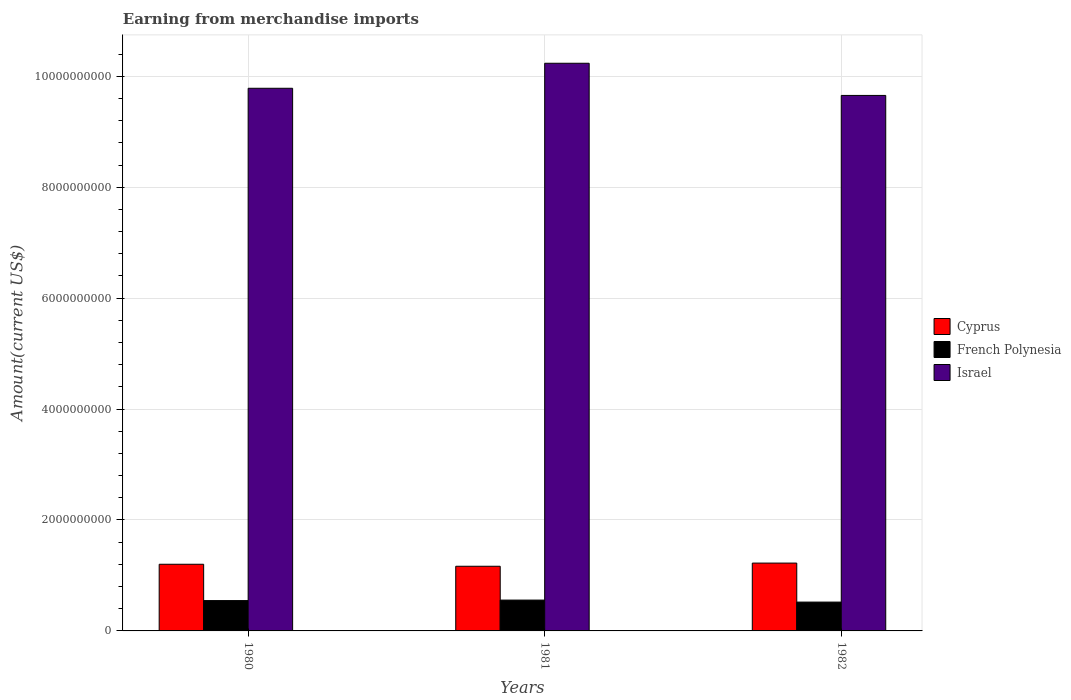How many bars are there on the 2nd tick from the left?
Make the answer very short. 3. What is the amount earned from merchandise imports in Israel in 1980?
Offer a very short reply. 9.78e+09. Across all years, what is the maximum amount earned from merchandise imports in Israel?
Make the answer very short. 1.02e+1. Across all years, what is the minimum amount earned from merchandise imports in Cyprus?
Your response must be concise. 1.17e+09. What is the total amount earned from merchandise imports in Israel in the graph?
Offer a very short reply. 2.97e+1. What is the difference between the amount earned from merchandise imports in Israel in 1981 and that in 1982?
Your response must be concise. 5.80e+08. What is the difference between the amount earned from merchandise imports in Cyprus in 1981 and the amount earned from merchandise imports in French Polynesia in 1980?
Offer a terse response. 6.19e+08. What is the average amount earned from merchandise imports in Cyprus per year?
Offer a terse response. 1.20e+09. In the year 1981, what is the difference between the amount earned from merchandise imports in French Polynesia and amount earned from merchandise imports in Cyprus?
Make the answer very short. -6.10e+08. What is the ratio of the amount earned from merchandise imports in Israel in 1980 to that in 1982?
Ensure brevity in your answer.  1.01. Is the amount earned from merchandise imports in French Polynesia in 1980 less than that in 1982?
Offer a very short reply. No. What is the difference between the highest and the second highest amount earned from merchandise imports in French Polynesia?
Give a very brief answer. 9.00e+06. What is the difference between the highest and the lowest amount earned from merchandise imports in Israel?
Provide a short and direct response. 5.80e+08. Is the sum of the amount earned from merchandise imports in French Polynesia in 1980 and 1982 greater than the maximum amount earned from merchandise imports in Cyprus across all years?
Provide a succinct answer. No. What does the 1st bar from the left in 1980 represents?
Make the answer very short. Cyprus. What does the 1st bar from the right in 1981 represents?
Offer a terse response. Israel. What is the difference between two consecutive major ticks on the Y-axis?
Your response must be concise. 2.00e+09. Are the values on the major ticks of Y-axis written in scientific E-notation?
Offer a very short reply. No. Where does the legend appear in the graph?
Provide a succinct answer. Center right. What is the title of the graph?
Give a very brief answer. Earning from merchandise imports. What is the label or title of the Y-axis?
Give a very brief answer. Amount(current US$). What is the Amount(current US$) of Cyprus in 1980?
Your response must be concise. 1.20e+09. What is the Amount(current US$) in French Polynesia in 1980?
Keep it short and to the point. 5.47e+08. What is the Amount(current US$) of Israel in 1980?
Give a very brief answer. 9.78e+09. What is the Amount(current US$) of Cyprus in 1981?
Offer a very short reply. 1.17e+09. What is the Amount(current US$) of French Polynesia in 1981?
Ensure brevity in your answer.  5.56e+08. What is the Amount(current US$) of Israel in 1981?
Your response must be concise. 1.02e+1. What is the Amount(current US$) in Cyprus in 1982?
Your answer should be very brief. 1.22e+09. What is the Amount(current US$) in French Polynesia in 1982?
Offer a terse response. 5.20e+08. What is the Amount(current US$) of Israel in 1982?
Offer a terse response. 9.66e+09. Across all years, what is the maximum Amount(current US$) in Cyprus?
Keep it short and to the point. 1.22e+09. Across all years, what is the maximum Amount(current US$) in French Polynesia?
Give a very brief answer. 5.56e+08. Across all years, what is the maximum Amount(current US$) in Israel?
Your response must be concise. 1.02e+1. Across all years, what is the minimum Amount(current US$) in Cyprus?
Your answer should be compact. 1.17e+09. Across all years, what is the minimum Amount(current US$) of French Polynesia?
Your answer should be very brief. 5.20e+08. Across all years, what is the minimum Amount(current US$) of Israel?
Keep it short and to the point. 9.66e+09. What is the total Amount(current US$) in Cyprus in the graph?
Give a very brief answer. 3.59e+09. What is the total Amount(current US$) of French Polynesia in the graph?
Provide a succinct answer. 1.62e+09. What is the total Amount(current US$) of Israel in the graph?
Make the answer very short. 2.97e+1. What is the difference between the Amount(current US$) in Cyprus in 1980 and that in 1981?
Provide a short and direct response. 3.60e+07. What is the difference between the Amount(current US$) of French Polynesia in 1980 and that in 1981?
Ensure brevity in your answer.  -9.00e+06. What is the difference between the Amount(current US$) in Israel in 1980 and that in 1981?
Give a very brief answer. -4.51e+08. What is the difference between the Amount(current US$) of Cyprus in 1980 and that in 1982?
Your response must be concise. -2.10e+07. What is the difference between the Amount(current US$) of French Polynesia in 1980 and that in 1982?
Give a very brief answer. 2.70e+07. What is the difference between the Amount(current US$) in Israel in 1980 and that in 1982?
Provide a short and direct response. 1.29e+08. What is the difference between the Amount(current US$) of Cyprus in 1981 and that in 1982?
Make the answer very short. -5.70e+07. What is the difference between the Amount(current US$) of French Polynesia in 1981 and that in 1982?
Your answer should be very brief. 3.60e+07. What is the difference between the Amount(current US$) of Israel in 1981 and that in 1982?
Provide a short and direct response. 5.80e+08. What is the difference between the Amount(current US$) in Cyprus in 1980 and the Amount(current US$) in French Polynesia in 1981?
Provide a succinct answer. 6.46e+08. What is the difference between the Amount(current US$) in Cyprus in 1980 and the Amount(current US$) in Israel in 1981?
Your response must be concise. -9.03e+09. What is the difference between the Amount(current US$) of French Polynesia in 1980 and the Amount(current US$) of Israel in 1981?
Make the answer very short. -9.69e+09. What is the difference between the Amount(current US$) of Cyprus in 1980 and the Amount(current US$) of French Polynesia in 1982?
Provide a succinct answer. 6.82e+08. What is the difference between the Amount(current US$) in Cyprus in 1980 and the Amount(current US$) in Israel in 1982?
Offer a very short reply. -8.45e+09. What is the difference between the Amount(current US$) of French Polynesia in 1980 and the Amount(current US$) of Israel in 1982?
Provide a short and direct response. -9.11e+09. What is the difference between the Amount(current US$) in Cyprus in 1981 and the Amount(current US$) in French Polynesia in 1982?
Provide a succinct answer. 6.46e+08. What is the difference between the Amount(current US$) in Cyprus in 1981 and the Amount(current US$) in Israel in 1982?
Make the answer very short. -8.49e+09. What is the difference between the Amount(current US$) of French Polynesia in 1981 and the Amount(current US$) of Israel in 1982?
Give a very brief answer. -9.10e+09. What is the average Amount(current US$) of Cyprus per year?
Provide a succinct answer. 1.20e+09. What is the average Amount(current US$) of French Polynesia per year?
Provide a succinct answer. 5.41e+08. What is the average Amount(current US$) in Israel per year?
Give a very brief answer. 9.89e+09. In the year 1980, what is the difference between the Amount(current US$) in Cyprus and Amount(current US$) in French Polynesia?
Provide a short and direct response. 6.55e+08. In the year 1980, what is the difference between the Amount(current US$) in Cyprus and Amount(current US$) in Israel?
Provide a short and direct response. -8.58e+09. In the year 1980, what is the difference between the Amount(current US$) of French Polynesia and Amount(current US$) of Israel?
Provide a succinct answer. -9.24e+09. In the year 1981, what is the difference between the Amount(current US$) in Cyprus and Amount(current US$) in French Polynesia?
Ensure brevity in your answer.  6.10e+08. In the year 1981, what is the difference between the Amount(current US$) of Cyprus and Amount(current US$) of Israel?
Ensure brevity in your answer.  -9.07e+09. In the year 1981, what is the difference between the Amount(current US$) of French Polynesia and Amount(current US$) of Israel?
Offer a very short reply. -9.68e+09. In the year 1982, what is the difference between the Amount(current US$) of Cyprus and Amount(current US$) of French Polynesia?
Offer a terse response. 7.03e+08. In the year 1982, what is the difference between the Amount(current US$) in Cyprus and Amount(current US$) in Israel?
Keep it short and to the point. -8.43e+09. In the year 1982, what is the difference between the Amount(current US$) of French Polynesia and Amount(current US$) of Israel?
Offer a very short reply. -9.14e+09. What is the ratio of the Amount(current US$) of Cyprus in 1980 to that in 1981?
Your answer should be compact. 1.03. What is the ratio of the Amount(current US$) of French Polynesia in 1980 to that in 1981?
Offer a terse response. 0.98. What is the ratio of the Amount(current US$) in Israel in 1980 to that in 1981?
Give a very brief answer. 0.96. What is the ratio of the Amount(current US$) in Cyprus in 1980 to that in 1982?
Offer a very short reply. 0.98. What is the ratio of the Amount(current US$) in French Polynesia in 1980 to that in 1982?
Provide a succinct answer. 1.05. What is the ratio of the Amount(current US$) of Israel in 1980 to that in 1982?
Ensure brevity in your answer.  1.01. What is the ratio of the Amount(current US$) in Cyprus in 1981 to that in 1982?
Your answer should be compact. 0.95. What is the ratio of the Amount(current US$) in French Polynesia in 1981 to that in 1982?
Your answer should be compact. 1.07. What is the ratio of the Amount(current US$) of Israel in 1981 to that in 1982?
Provide a short and direct response. 1.06. What is the difference between the highest and the second highest Amount(current US$) in Cyprus?
Your response must be concise. 2.10e+07. What is the difference between the highest and the second highest Amount(current US$) in French Polynesia?
Provide a short and direct response. 9.00e+06. What is the difference between the highest and the second highest Amount(current US$) in Israel?
Provide a succinct answer. 4.51e+08. What is the difference between the highest and the lowest Amount(current US$) of Cyprus?
Provide a short and direct response. 5.70e+07. What is the difference between the highest and the lowest Amount(current US$) of French Polynesia?
Your answer should be very brief. 3.60e+07. What is the difference between the highest and the lowest Amount(current US$) in Israel?
Your answer should be compact. 5.80e+08. 